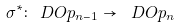<formula> <loc_0><loc_0><loc_500><loc_500>\sigma ^ { * } \colon \ D O p _ { n - 1 } \rightarrow \ D O p _ { n }</formula> 